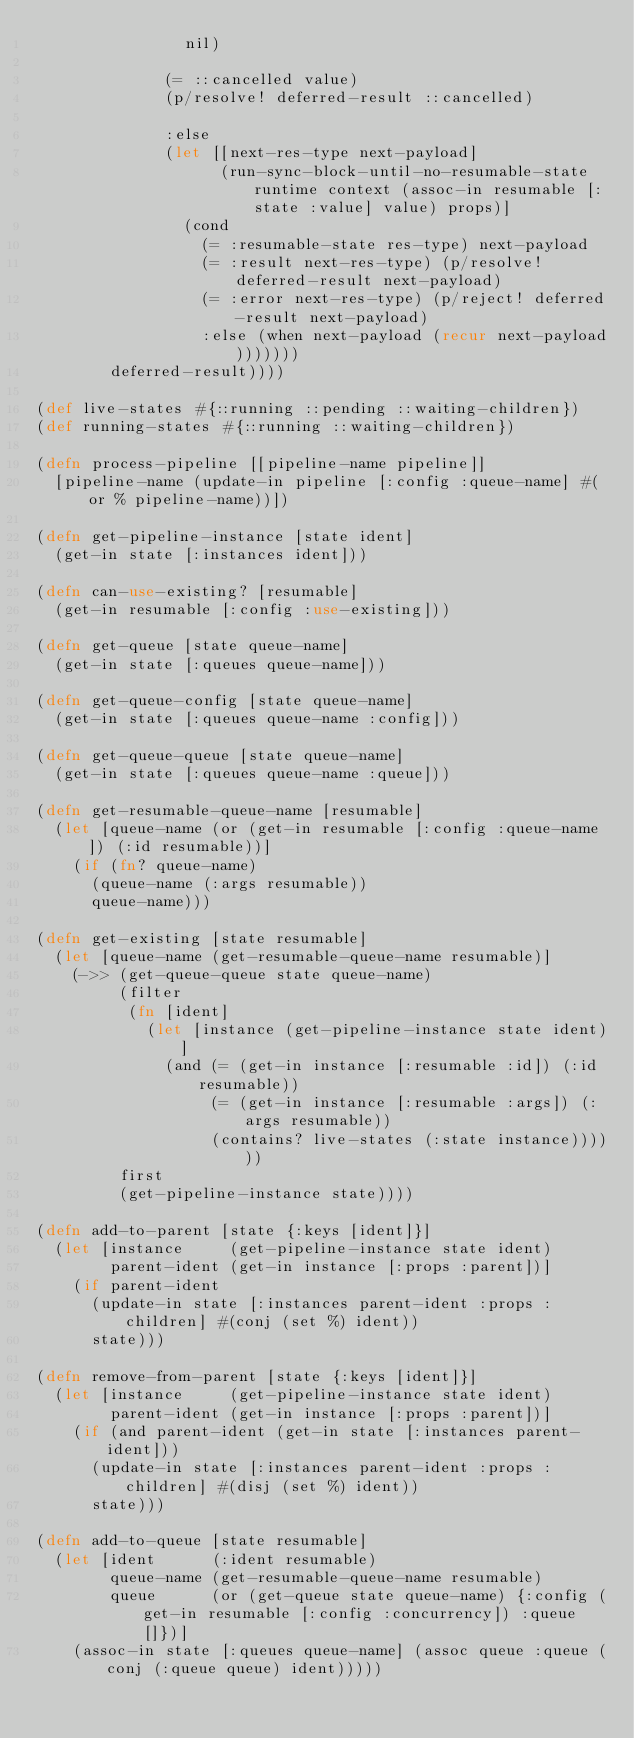Convert code to text. <code><loc_0><loc_0><loc_500><loc_500><_Clojure_>                nil)

              (= ::cancelled value)
              (p/resolve! deferred-result ::cancelled)

              :else
              (let [[next-res-type next-payload]
                    (run-sync-block-until-no-resumable-state runtime context (assoc-in resumable [:state :value] value) props)]
                (cond
                  (= :resumable-state res-type) next-payload
                  (= :result next-res-type) (p/resolve! deferred-result next-payload)
                  (= :error next-res-type) (p/reject! deferred-result next-payload)
                  :else (when next-payload (recur next-payload)))))))
        deferred-result))))

(def live-states #{::running ::pending ::waiting-children})
(def running-states #{::running ::waiting-children})

(defn process-pipeline [[pipeline-name pipeline]]
  [pipeline-name (update-in pipeline [:config :queue-name] #(or % pipeline-name))])

(defn get-pipeline-instance [state ident]
  (get-in state [:instances ident]))

(defn can-use-existing? [resumable]
  (get-in resumable [:config :use-existing]))

(defn get-queue [state queue-name]
  (get-in state [:queues queue-name]))

(defn get-queue-config [state queue-name]
  (get-in state [:queues queue-name :config]))

(defn get-queue-queue [state queue-name]
  (get-in state [:queues queue-name :queue]))

(defn get-resumable-queue-name [resumable]
  (let [queue-name (or (get-in resumable [:config :queue-name]) (:id resumable))]
    (if (fn? queue-name)
      (queue-name (:args resumable))
      queue-name)))

(defn get-existing [state resumable]
  (let [queue-name (get-resumable-queue-name resumable)]
    (->> (get-queue-queue state queue-name)
         (filter
          (fn [ident]
            (let [instance (get-pipeline-instance state ident)]
              (and (= (get-in instance [:resumable :id]) (:id resumable))
                   (= (get-in instance [:resumable :args]) (:args resumable))
                   (contains? live-states (:state instance))))))
         first
         (get-pipeline-instance state))))

(defn add-to-parent [state {:keys [ident]}]
  (let [instance     (get-pipeline-instance state ident)
        parent-ident (get-in instance [:props :parent])]
    (if parent-ident
      (update-in state [:instances parent-ident :props :children] #(conj (set %) ident))
      state)))

(defn remove-from-parent [state {:keys [ident]}]
  (let [instance     (get-pipeline-instance state ident)
        parent-ident (get-in instance [:props :parent])]
    (if (and parent-ident (get-in state [:instances parent-ident]))
      (update-in state [:instances parent-ident :props :children] #(disj (set %) ident))
      state)))

(defn add-to-queue [state resumable]
  (let [ident      (:ident resumable)
        queue-name (get-resumable-queue-name resumable)
        queue      (or (get-queue state queue-name) {:config (get-in resumable [:config :concurrency]) :queue []})]
    (assoc-in state [:queues queue-name] (assoc queue :queue (conj (:queue queue) ident)))))
</code> 